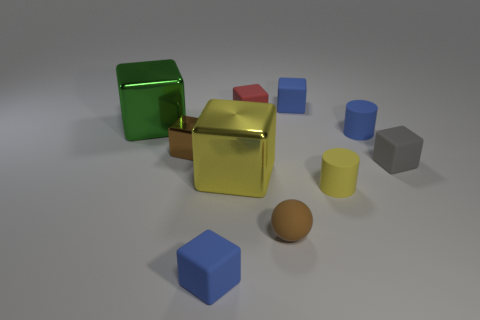Is the yellow cylinder the same size as the yellow block?
Provide a succinct answer. No. Are there any yellow blocks that have the same material as the ball?
Ensure brevity in your answer.  No. There is a shiny block that is the same color as the tiny ball; what size is it?
Provide a succinct answer. Small. What number of tiny blue rubber blocks are both in front of the tiny shiny object and behind the red matte block?
Give a very brief answer. 0. There is a blue thing that is left of the tiny red rubber object; what material is it?
Your response must be concise. Rubber. What number of small rubber things have the same color as the sphere?
Make the answer very short. 0. The yellow cylinder that is made of the same material as the gray object is what size?
Your response must be concise. Small. How many things are either blue rubber blocks or big blocks?
Your answer should be compact. 4. There is a small rubber object in front of the tiny brown matte ball; what color is it?
Keep it short and to the point. Blue. There is another thing that is the same shape as the yellow matte thing; what size is it?
Your answer should be compact. Small. 